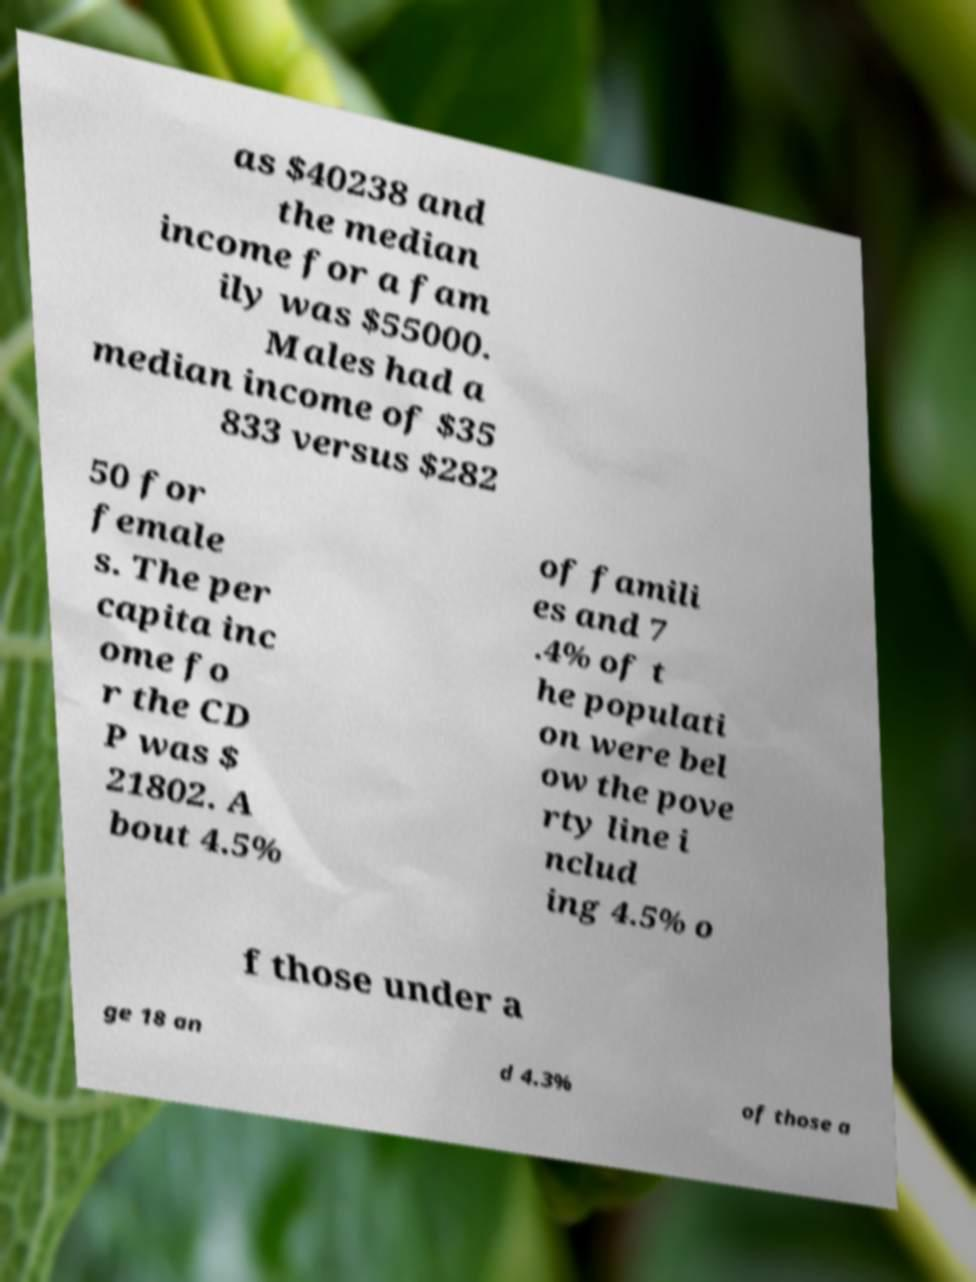Can you read and provide the text displayed in the image?This photo seems to have some interesting text. Can you extract and type it out for me? as $40238 and the median income for a fam ily was $55000. Males had a median income of $35 833 versus $282 50 for female s. The per capita inc ome fo r the CD P was $ 21802. A bout 4.5% of famili es and 7 .4% of t he populati on were bel ow the pove rty line i nclud ing 4.5% o f those under a ge 18 an d 4.3% of those a 